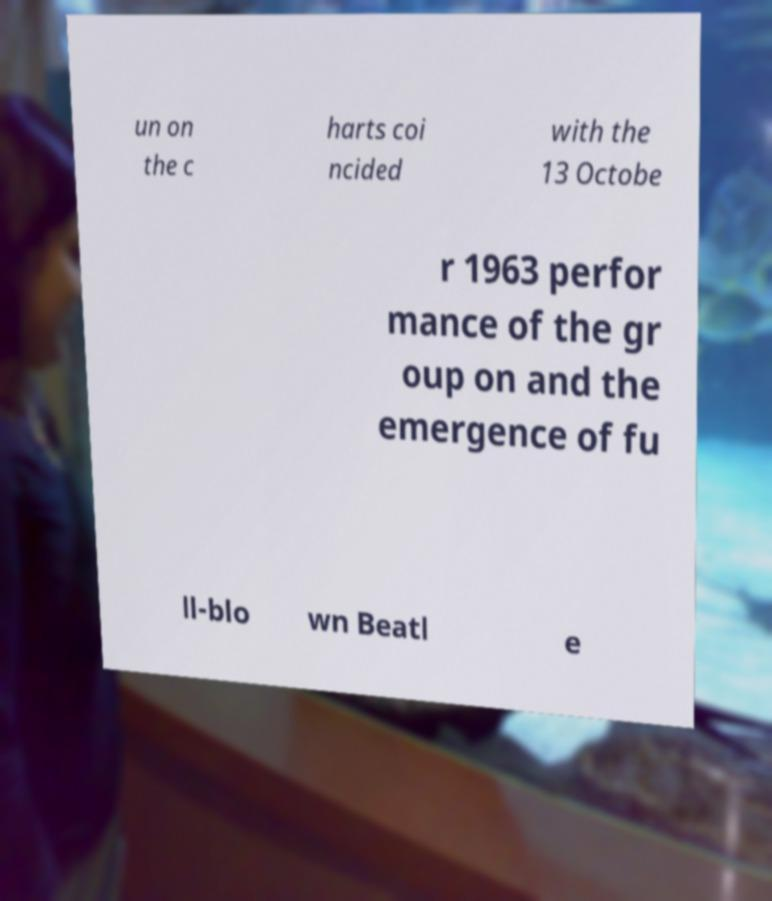Please identify and transcribe the text found in this image. un on the c harts coi ncided with the 13 Octobe r 1963 perfor mance of the gr oup on and the emergence of fu ll-blo wn Beatl e 